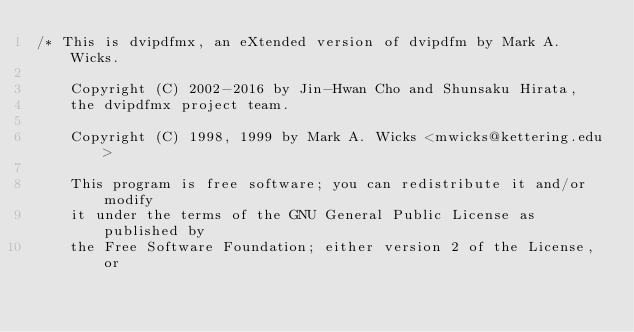<code> <loc_0><loc_0><loc_500><loc_500><_Rust_>/* This is dvipdfmx, an eXtended version of dvipdfm by Mark A. Wicks.

    Copyright (C) 2002-2016 by Jin-Hwan Cho and Shunsaku Hirata,
    the dvipdfmx project team.

    Copyright (C) 1998, 1999 by Mark A. Wicks <mwicks@kettering.edu>

    This program is free software; you can redistribute it and/or modify
    it under the terms of the GNU General Public License as published by
    the Free Software Foundation; either version 2 of the License, or</code> 